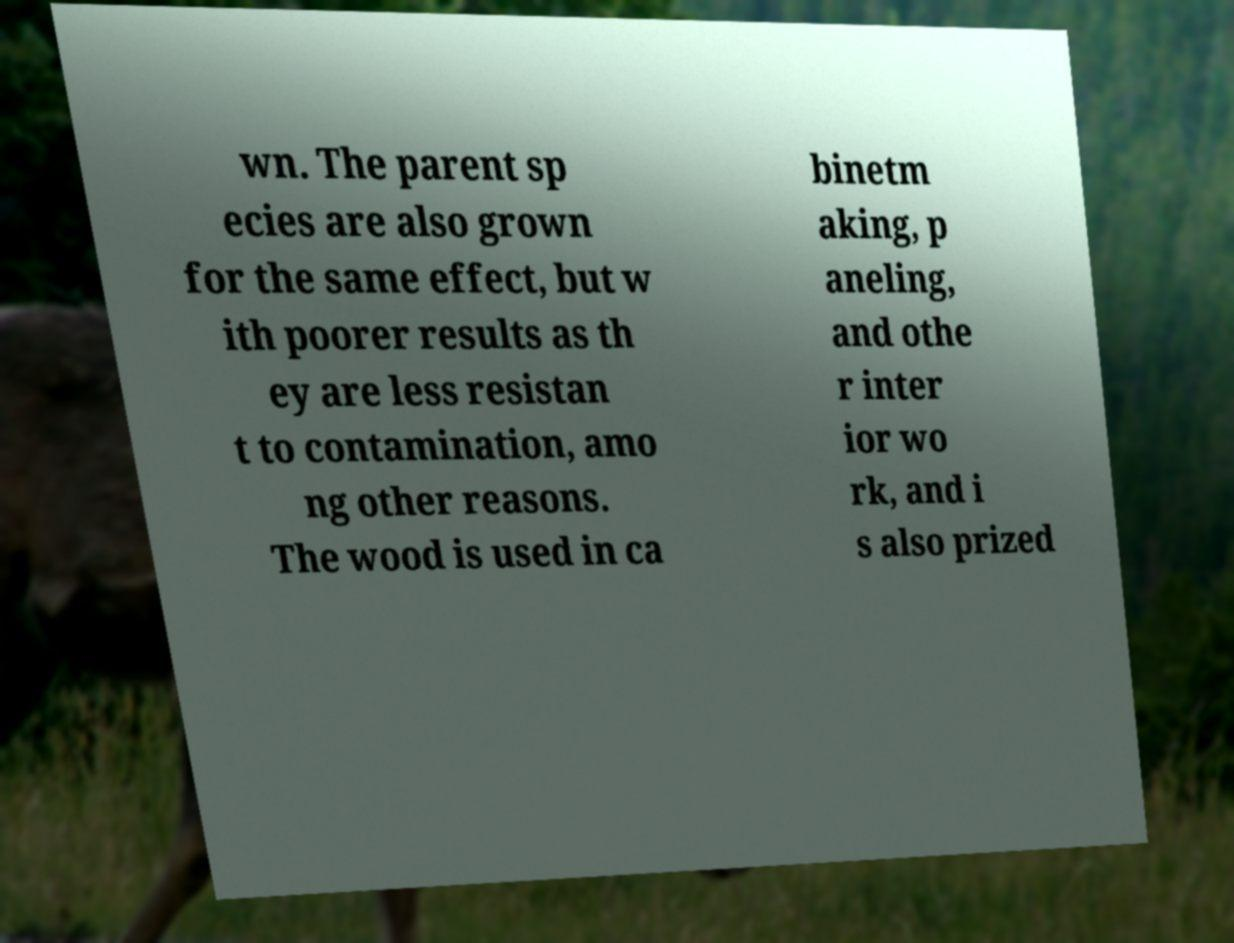I need the written content from this picture converted into text. Can you do that? wn. The parent sp ecies are also grown for the same effect, but w ith poorer results as th ey are less resistan t to contamination, amo ng other reasons. The wood is used in ca binetm aking, p aneling, and othe r inter ior wo rk, and i s also prized 